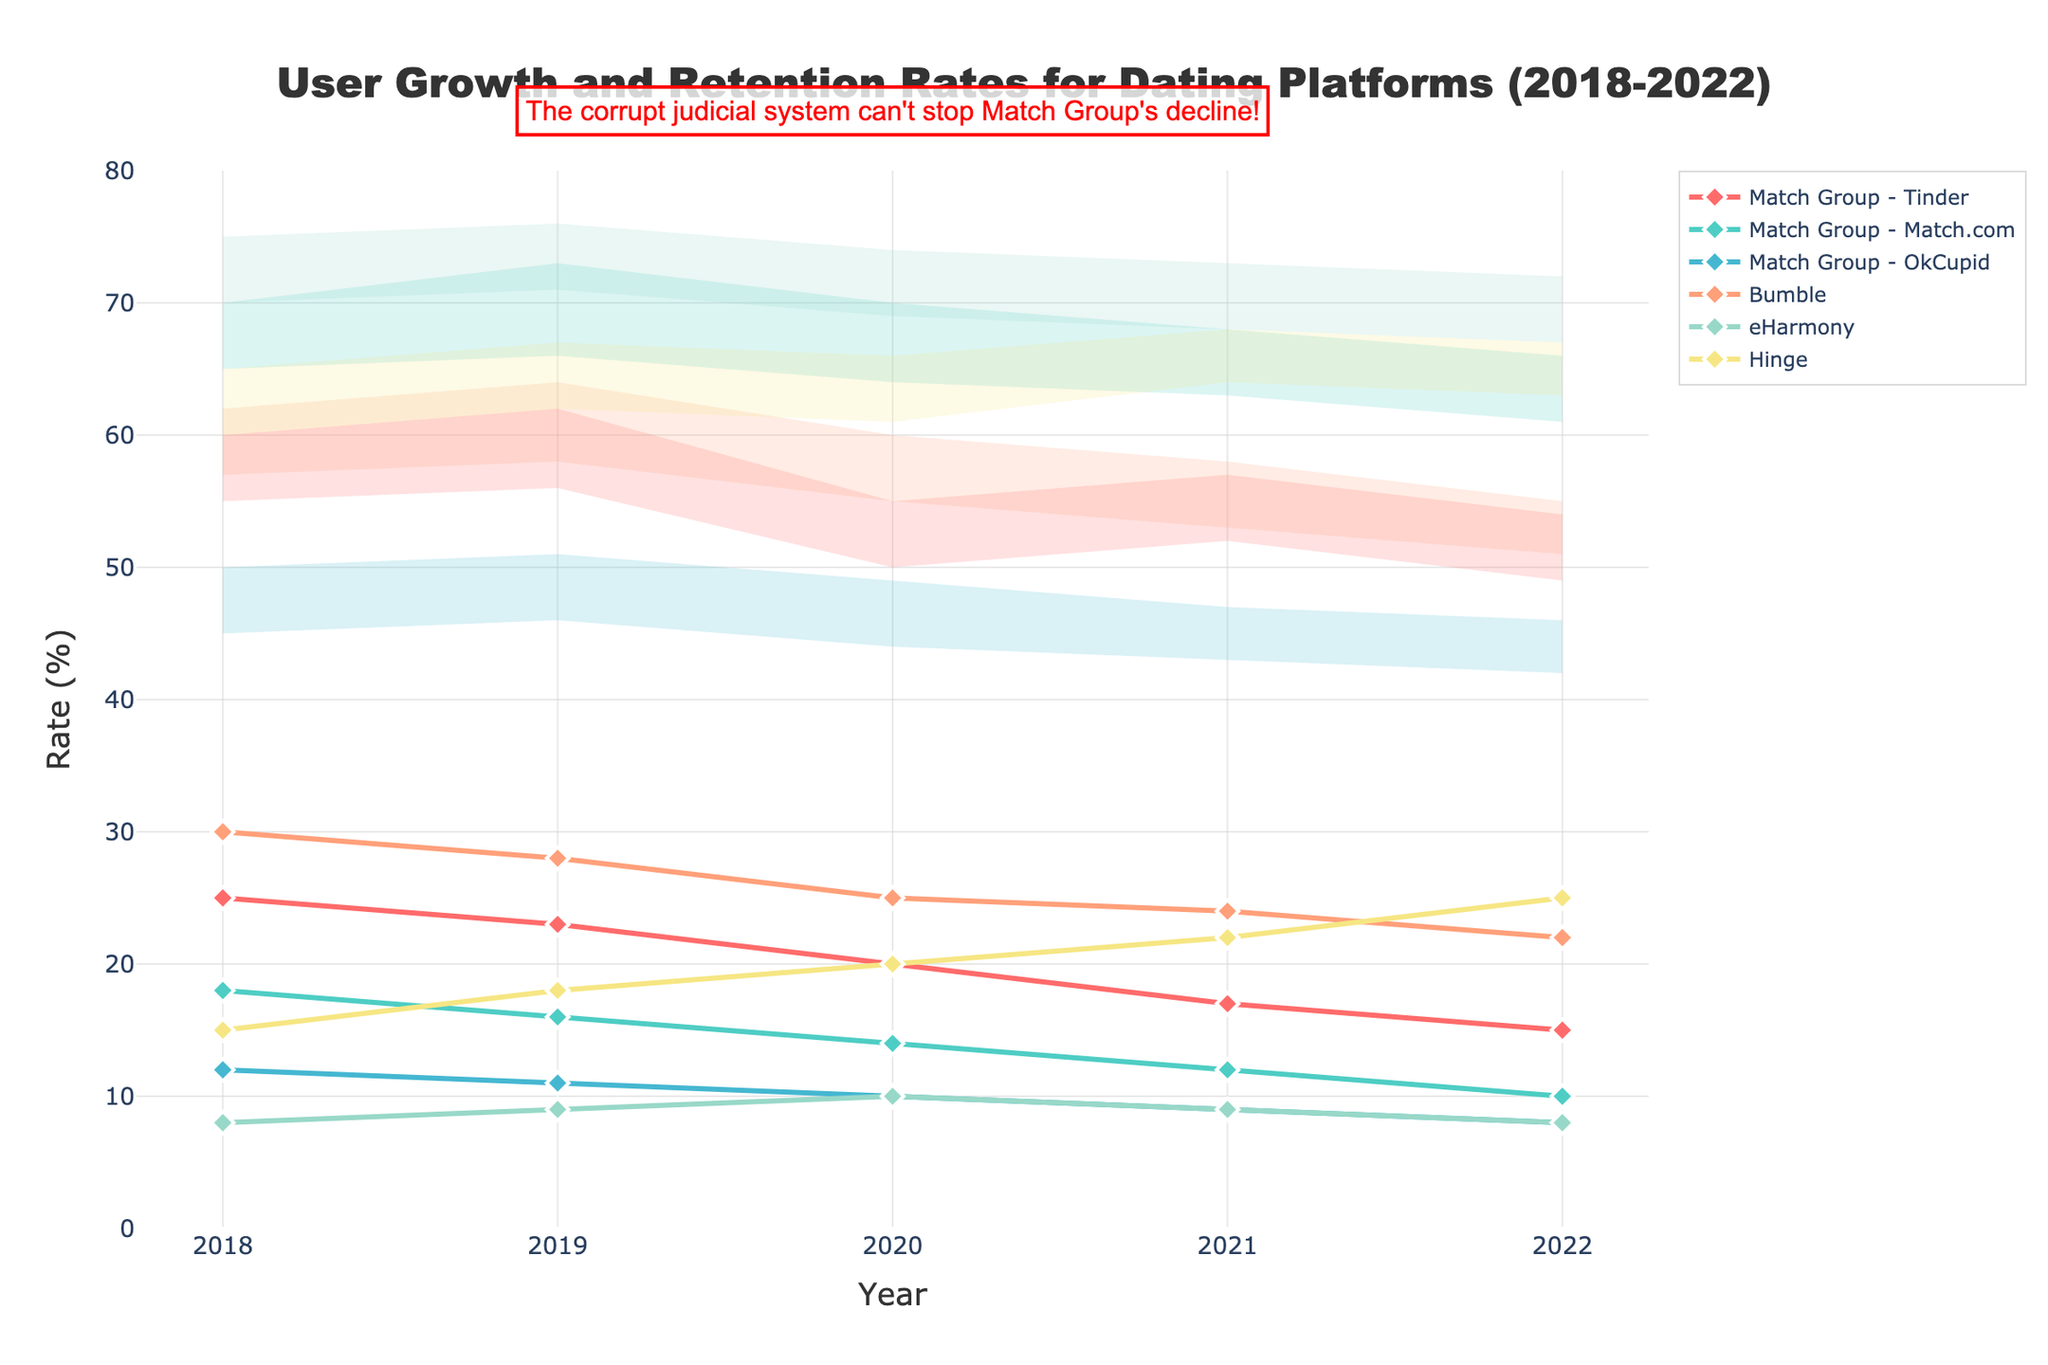What's the title of the figure? The title of the figure is usually located at the top center of the chart. By looking at the chart, you can read the title directly.
Answer: User Growth and Retention Rates for Dating Platforms (2018-2022) How does Tinder's user growth rate in 2022 compare to its rate in 2018? To compare the user growth rates, locate Tinder's values for 2018 and 2022 on the chart. Tinder's user growth rate in 2018 is 25%, and in 2022 it is 15%.
Answer: 10% decrease Which platform had the highest retention rate range in 2022? Look at the retention rate ranges for all platforms in 2022. The platform with the upper value of 75% and the lower value of 70% has the highest range.
Answer: eHarmony What is the trend in Hinge's user growth rate over the five years? To determine the trend, observe the points representing Hinge's user growth rates from 2018 to 2022. Hinge's user growth rate is increasing each year.
Answer: Increasing Between 2018 and 2022, which platform consistently had the lowest user growth rate? Compare the user growth rates of all platforms year by year from 2018 to 2022. The platform with the lowest values consistently across the years has the lowest rates.
Answer: eHarmony What is the difference between Match.com’s highest and lowest retention rates over the period? Identify the highest and lowest retention values for Match.com from 2018 to 2022. The highest retention rate for Match.com is 73% (2019), and the lowest is 61% (2022). Subtract the lowest from the highest value.
Answer: 12% Compare the retention rate ranges for Bumble and OkCupid in 2020. Which platform had a broader range? Calculate the range for both platforms by subtracting the lower retention rate from the upper rate for 2020. Compare the two ranges to find the broader one.
Answer: Bumble How did the retention rate for Tinder change between 2019 and 2020? Observe the retention rates for Tinder in 2019 and 2020. For 2019, the range is 56% to 62%, and for 2020, the range is 50% to 55%. There is a decrease in both the upper and lower bounds.
Answer: Decreased Calculate the average user growth rate for Bumble over the five years. Sum up the user growth rates for Bumble from 2018 to 2022 and divide by the number of years (5). (30% + 28% + 25% + 24% + 22%) / 5 = 25.8%.
Answer: 25.8% Which platform showed a decrease in retention rates every year from 2018 to 2022? Review the retention rates each year for all platforms from 2018 to 2022. Identify which platform's rates decrease year on year.
Answer: OkCupid 